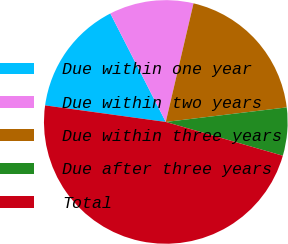<chart> <loc_0><loc_0><loc_500><loc_500><pie_chart><fcel>Due within one year<fcel>Due within two years<fcel>Due within three years<fcel>Due after three years<fcel>Total<nl><fcel>15.31%<fcel>11.18%<fcel>19.44%<fcel>6.38%<fcel>47.7%<nl></chart> 